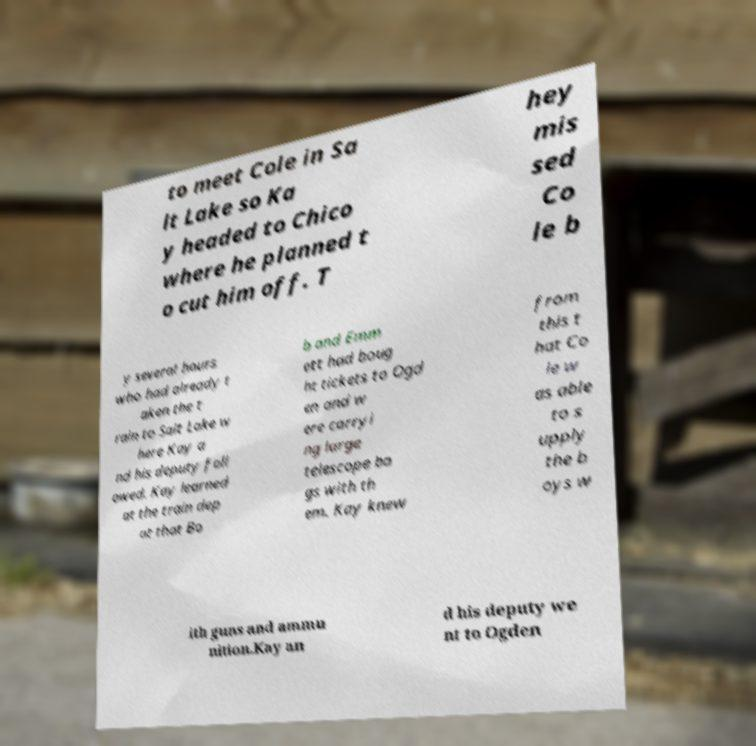For documentation purposes, I need the text within this image transcribed. Could you provide that? to meet Cole in Sa lt Lake so Ka y headed to Chico where he planned t o cut him off. T hey mis sed Co le b y several hours who had already t aken the t rain to Salt Lake w here Kay a nd his deputy foll owed. Kay learned at the train dep ot that Bo b and Emm ett had boug ht tickets to Ogd en and w ere carryi ng large telescope ba gs with th em. Kay knew from this t hat Co le w as able to s upply the b oys w ith guns and ammu nition.Kay an d his deputy we nt to Ogden 